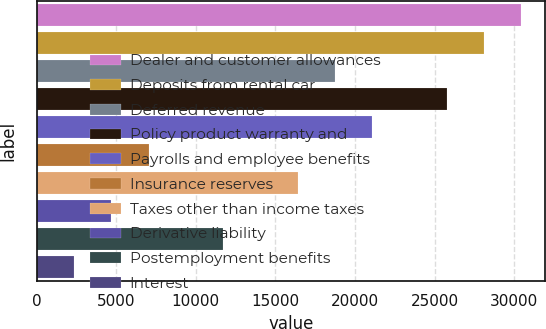Convert chart to OTSL. <chart><loc_0><loc_0><loc_500><loc_500><bar_chart><fcel>Dealer and customer allowances<fcel>Deposits from rental car<fcel>Deferred revenue<fcel>Policy product warranty and<fcel>Payrolls and employee benefits<fcel>Insurance reserves<fcel>Taxes other than income taxes<fcel>Derivative liability<fcel>Postemployment benefits<fcel>Interest<nl><fcel>30437.8<fcel>28098.2<fcel>18739.8<fcel>25758.6<fcel>21079.4<fcel>7041.8<fcel>16400.2<fcel>4702.2<fcel>11721<fcel>2362.6<nl></chart> 